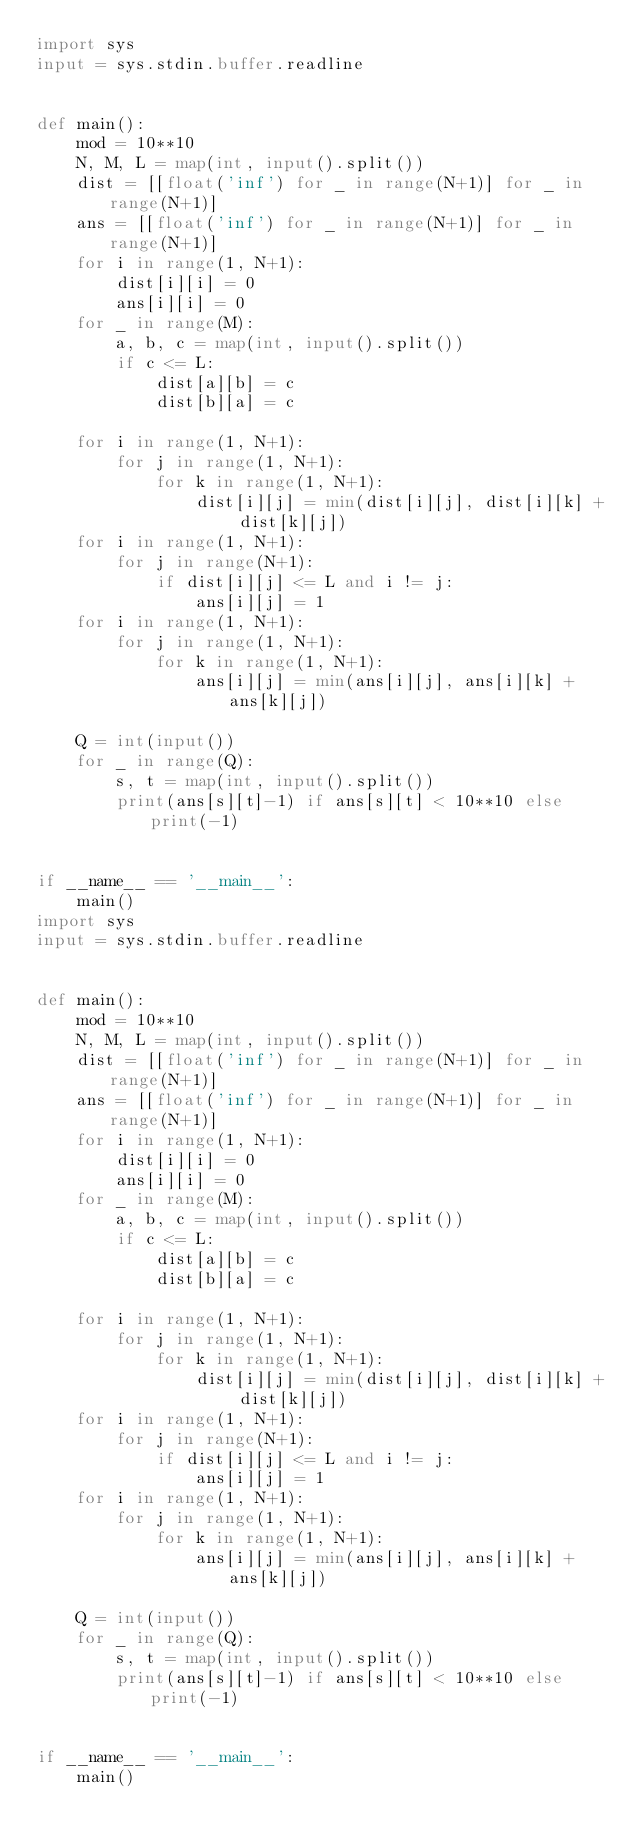Convert code to text. <code><loc_0><loc_0><loc_500><loc_500><_Python_>import sys
input = sys.stdin.buffer.readline


def main():
    mod = 10**10
    N, M, L = map(int, input().split())
    dist = [[float('inf') for _ in range(N+1)] for _ in range(N+1)]
    ans = [[float('inf') for _ in range(N+1)] for _ in range(N+1)]
    for i in range(1, N+1):
        dist[i][i] = 0
        ans[i][i] = 0
    for _ in range(M):
        a, b, c = map(int, input().split())
        if c <= L:
            dist[a][b] = c
            dist[b][a] = c

    for i in range(1, N+1):
        for j in range(1, N+1):
            for k in range(1, N+1):
                dist[i][j] = min(dist[i][j], dist[i][k] + dist[k][j])
    for i in range(1, N+1):
        for j in range(N+1):
            if dist[i][j] <= L and i != j:
                ans[i][j] = 1
    for i in range(1, N+1):
        for j in range(1, N+1):
            for k in range(1, N+1):
                ans[i][j] = min(ans[i][j], ans[i][k] + ans[k][j])

    Q = int(input())
    for _ in range(Q):
        s, t = map(int, input().split())
        print(ans[s][t]-1) if ans[s][t] < 10**10 else print(-1)


if __name__ == '__main__':
    main()
import sys
input = sys.stdin.buffer.readline


def main():
    mod = 10**10
    N, M, L = map(int, input().split())
    dist = [[float('inf') for _ in range(N+1)] for _ in range(N+1)]
    ans = [[float('inf') for _ in range(N+1)] for _ in range(N+1)]
    for i in range(1, N+1):
        dist[i][i] = 0
        ans[i][i] = 0
    for _ in range(M):
        a, b, c = map(int, input().split())
        if c <= L:
            dist[a][b] = c
            dist[b][a] = c

    for i in range(1, N+1):
        for j in range(1, N+1):
            for k in range(1, N+1):
                dist[i][j] = min(dist[i][j], dist[i][k] + dist[k][j])
    for i in range(1, N+1):
        for j in range(N+1):
            if dist[i][j] <= L and i != j:
                ans[i][j] = 1
    for i in range(1, N+1):
        for j in range(1, N+1):
            for k in range(1, N+1):
                ans[i][j] = min(ans[i][j], ans[i][k] + ans[k][j])

    Q = int(input())
    for _ in range(Q):
        s, t = map(int, input().split())
        print(ans[s][t]-1) if ans[s][t] < 10**10 else print(-1)


if __name__ == '__main__':
    main()
</code> 